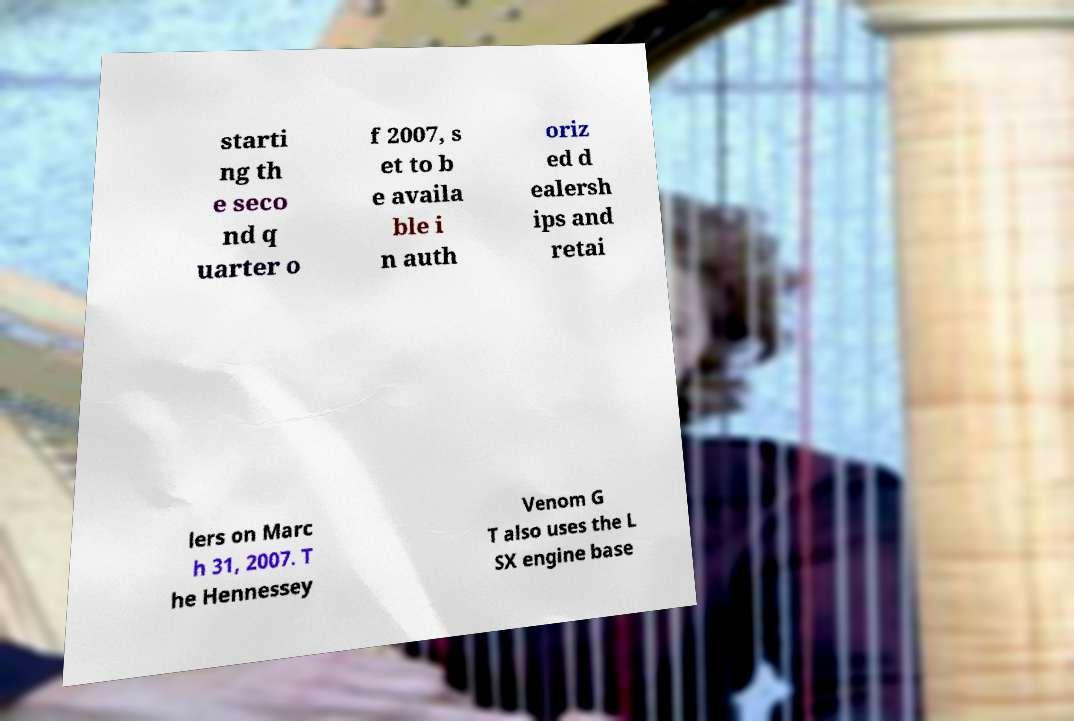Please identify and transcribe the text found in this image. starti ng th e seco nd q uarter o f 2007, s et to b e availa ble i n auth oriz ed d ealersh ips and retai lers on Marc h 31, 2007. T he Hennessey Venom G T also uses the L SX engine base 